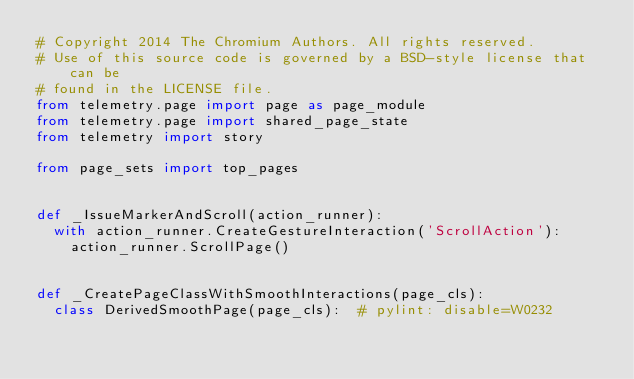Convert code to text. <code><loc_0><loc_0><loc_500><loc_500><_Python_># Copyright 2014 The Chromium Authors. All rights reserved.
# Use of this source code is governed by a BSD-style license that can be
# found in the LICENSE file.
from telemetry.page import page as page_module
from telemetry.page import shared_page_state
from telemetry import story

from page_sets import top_pages


def _IssueMarkerAndScroll(action_runner):
  with action_runner.CreateGestureInteraction('ScrollAction'):
    action_runner.ScrollPage()


def _CreatePageClassWithSmoothInteractions(page_cls):
  class DerivedSmoothPage(page_cls):  # pylint: disable=W0232
</code> 